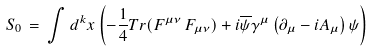Convert formula to latex. <formula><loc_0><loc_0><loc_500><loc_500>S _ { 0 } \, = \, \int d ^ { k } x \left ( - { \frac { 1 } { 4 } } T r ( F ^ { \mu \nu } \, F _ { \mu \nu } ) + i \overline { \psi } \gamma ^ { \mu } \left ( \partial _ { \mu } - i A _ { \mu } \right ) \psi \right )</formula> 